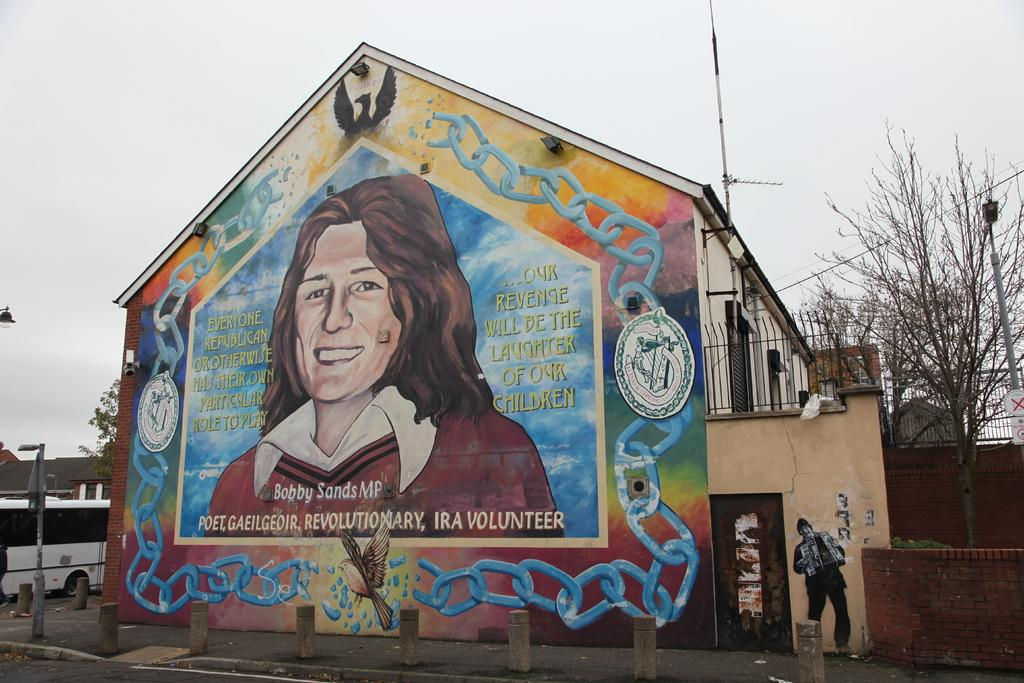What type of structure is visible in the image? There is a house in the image. What else can be seen in the image besides the house? There is a vehicle, the rooftop, poles, lights, boards, railings, objects, and a painting on the walls visible in the image. What is visible in the background of the image? The sky and trees are visible in the background of the image. Can you see the squirrel's hands in the image? There is no squirrel present in the image, so it is not possible to see its hands. 